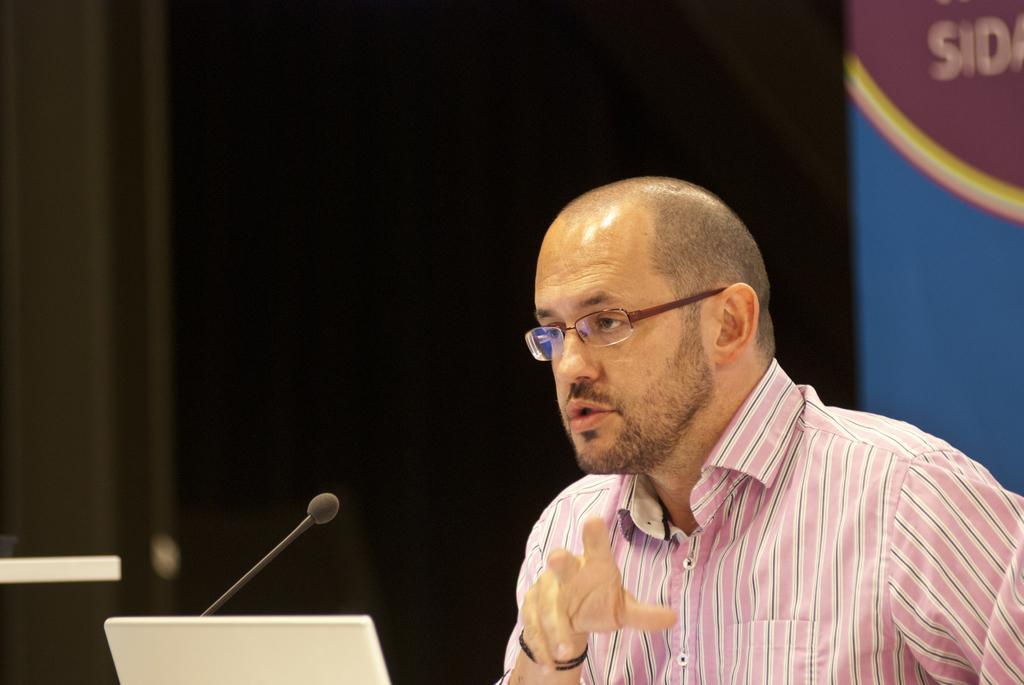Can you describe this image briefly? In this image I can see a person wearing white and pink color shirt, in front I can see a laptop and a microphone and I can see dark background. 